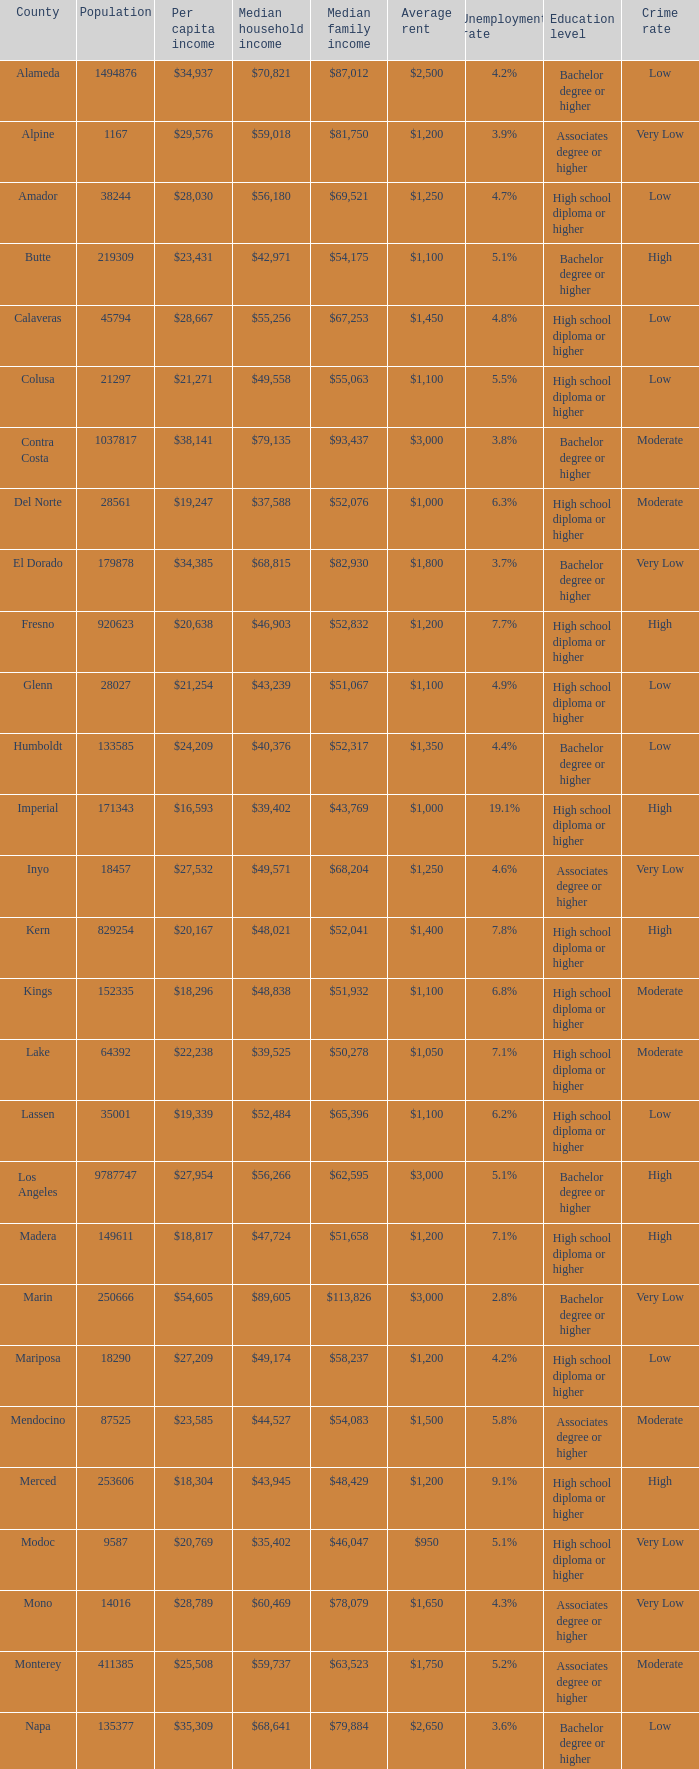What is the median household income of butte? $42,971. 